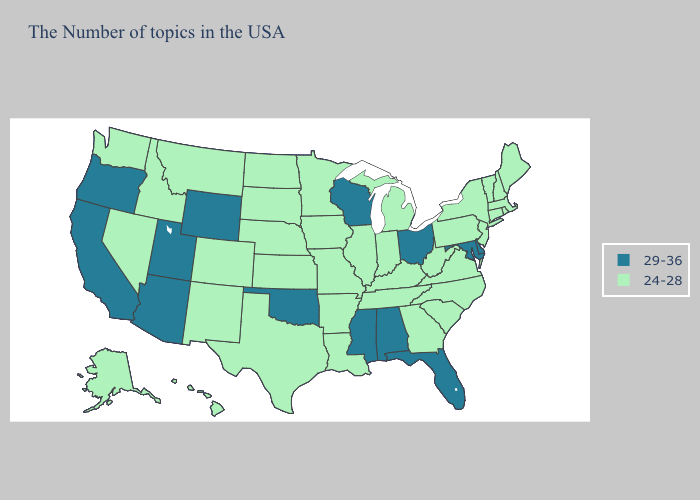Does the map have missing data?
Give a very brief answer. No. Does Montana have the highest value in the West?
Concise answer only. No. What is the value of Maine?
Keep it brief. 24-28. Does Colorado have a lower value than New York?
Be succinct. No. What is the highest value in the USA?
Concise answer only. 29-36. What is the lowest value in the USA?
Write a very short answer. 24-28. Name the states that have a value in the range 29-36?
Be succinct. Delaware, Maryland, Ohio, Florida, Alabama, Wisconsin, Mississippi, Oklahoma, Wyoming, Utah, Arizona, California, Oregon. Which states hav the highest value in the MidWest?
Write a very short answer. Ohio, Wisconsin. Does Utah have the highest value in the USA?
Quick response, please. Yes. What is the value of Massachusetts?
Keep it brief. 24-28. Name the states that have a value in the range 29-36?
Short answer required. Delaware, Maryland, Ohio, Florida, Alabama, Wisconsin, Mississippi, Oklahoma, Wyoming, Utah, Arizona, California, Oregon. Does the first symbol in the legend represent the smallest category?
Answer briefly. No. 